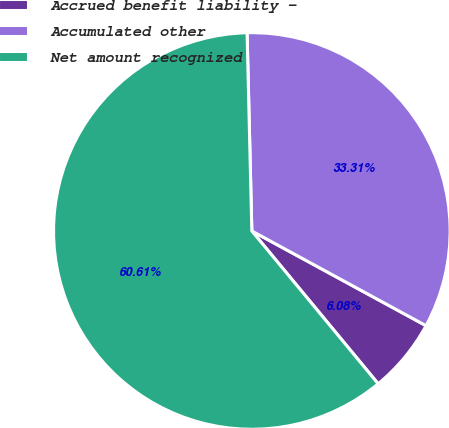<chart> <loc_0><loc_0><loc_500><loc_500><pie_chart><fcel>Accrued benefit liability -<fcel>Accumulated other<fcel>Net amount recognized<nl><fcel>6.08%<fcel>33.31%<fcel>60.61%<nl></chart> 